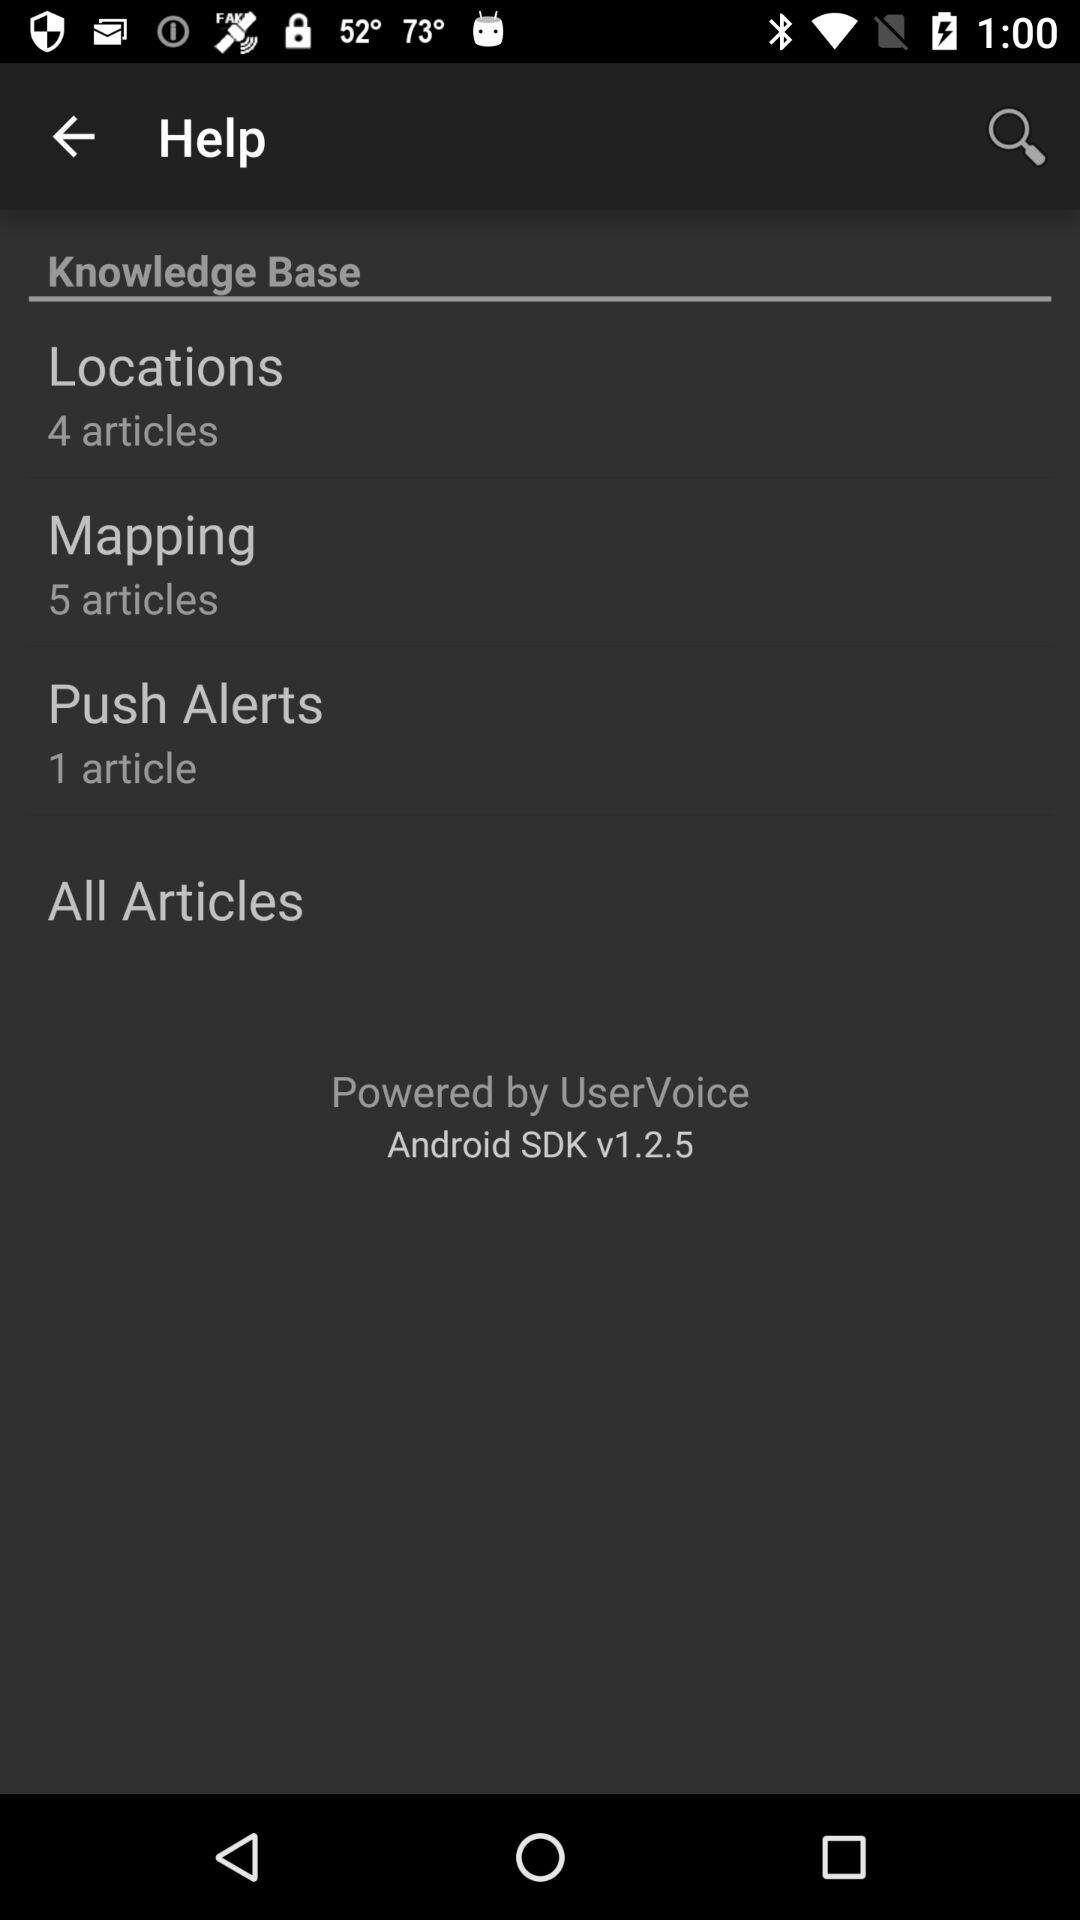What is the app name?
When the provided information is insufficient, respond with <no answer>. <no answer> 